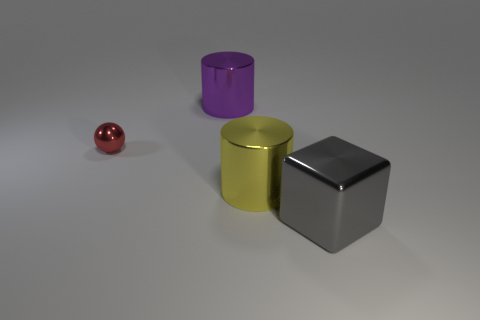Subtract all brown cylinders. Subtract all red cubes. How many cylinders are left? 2 Add 1 gray matte things. How many objects exist? 5 Subtract all spheres. How many objects are left? 3 Add 3 yellow metallic objects. How many yellow metallic objects are left? 4 Add 1 small gray metallic spheres. How many small gray metallic spheres exist? 1 Subtract 0 green balls. How many objects are left? 4 Subtract all small red shiny objects. Subtract all big yellow cylinders. How many objects are left? 2 